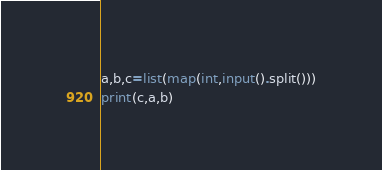<code> <loc_0><loc_0><loc_500><loc_500><_Python_>a,b,c=list(map(int,input().split()))
print(c,a,b)</code> 